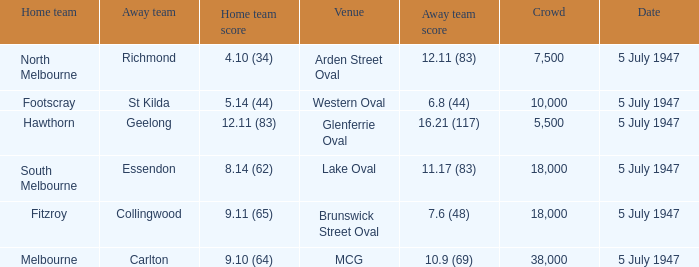Where was the game played where the away team has a score of 7.6 (48)? Brunswick Street Oval. 